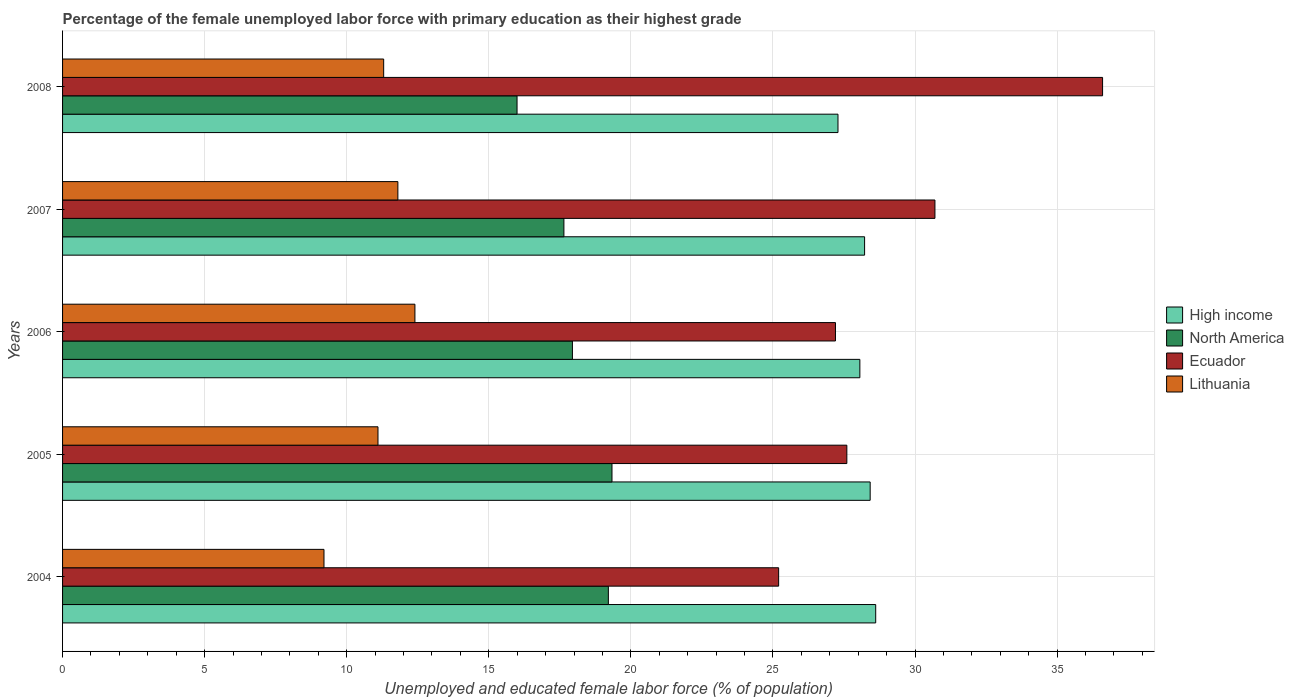How many different coloured bars are there?
Provide a short and direct response. 4. Are the number of bars on each tick of the Y-axis equal?
Provide a short and direct response. Yes. How many bars are there on the 1st tick from the top?
Ensure brevity in your answer.  4. How many bars are there on the 1st tick from the bottom?
Make the answer very short. 4. In how many cases, is the number of bars for a given year not equal to the number of legend labels?
Give a very brief answer. 0. What is the percentage of the unemployed female labor force with primary education in High income in 2006?
Ensure brevity in your answer.  28.06. Across all years, what is the maximum percentage of the unemployed female labor force with primary education in Ecuador?
Ensure brevity in your answer.  36.6. Across all years, what is the minimum percentage of the unemployed female labor force with primary education in High income?
Provide a short and direct response. 27.29. What is the total percentage of the unemployed female labor force with primary education in North America in the graph?
Provide a short and direct response. 90.12. What is the difference between the percentage of the unemployed female labor force with primary education in High income in 2007 and that in 2008?
Give a very brief answer. 0.94. What is the difference between the percentage of the unemployed female labor force with primary education in Lithuania in 2004 and the percentage of the unemployed female labor force with primary education in North America in 2008?
Provide a succinct answer. -6.79. What is the average percentage of the unemployed female labor force with primary education in High income per year?
Your answer should be very brief. 28.12. In the year 2005, what is the difference between the percentage of the unemployed female labor force with primary education in High income and percentage of the unemployed female labor force with primary education in Lithuania?
Your answer should be compact. 17.32. What is the ratio of the percentage of the unemployed female labor force with primary education in North America in 2005 to that in 2008?
Offer a terse response. 1.21. Is the difference between the percentage of the unemployed female labor force with primary education in High income in 2005 and 2007 greater than the difference between the percentage of the unemployed female labor force with primary education in Lithuania in 2005 and 2007?
Offer a very short reply. Yes. What is the difference between the highest and the second highest percentage of the unemployed female labor force with primary education in North America?
Keep it short and to the point. 0.13. What is the difference between the highest and the lowest percentage of the unemployed female labor force with primary education in Ecuador?
Keep it short and to the point. 11.4. In how many years, is the percentage of the unemployed female labor force with primary education in North America greater than the average percentage of the unemployed female labor force with primary education in North America taken over all years?
Provide a succinct answer. 2. Is the sum of the percentage of the unemployed female labor force with primary education in High income in 2004 and 2007 greater than the maximum percentage of the unemployed female labor force with primary education in North America across all years?
Your answer should be compact. Yes. What does the 2nd bar from the top in 2008 represents?
Provide a short and direct response. Ecuador. Is it the case that in every year, the sum of the percentage of the unemployed female labor force with primary education in Ecuador and percentage of the unemployed female labor force with primary education in Lithuania is greater than the percentage of the unemployed female labor force with primary education in North America?
Make the answer very short. Yes. How many years are there in the graph?
Ensure brevity in your answer.  5. What is the difference between two consecutive major ticks on the X-axis?
Provide a short and direct response. 5. Does the graph contain any zero values?
Keep it short and to the point. No. Does the graph contain grids?
Give a very brief answer. Yes. Where does the legend appear in the graph?
Make the answer very short. Center right. How many legend labels are there?
Offer a very short reply. 4. How are the legend labels stacked?
Your response must be concise. Vertical. What is the title of the graph?
Give a very brief answer. Percentage of the female unemployed labor force with primary education as their highest grade. Does "Singapore" appear as one of the legend labels in the graph?
Provide a short and direct response. No. What is the label or title of the X-axis?
Keep it short and to the point. Unemployed and educated female labor force (% of population). What is the label or title of the Y-axis?
Make the answer very short. Years. What is the Unemployed and educated female labor force (% of population) of High income in 2004?
Give a very brief answer. 28.62. What is the Unemployed and educated female labor force (% of population) in North America in 2004?
Make the answer very short. 19.21. What is the Unemployed and educated female labor force (% of population) of Ecuador in 2004?
Offer a terse response. 25.2. What is the Unemployed and educated female labor force (% of population) in Lithuania in 2004?
Offer a very short reply. 9.2. What is the Unemployed and educated female labor force (% of population) of High income in 2005?
Your response must be concise. 28.42. What is the Unemployed and educated female labor force (% of population) of North America in 2005?
Offer a terse response. 19.33. What is the Unemployed and educated female labor force (% of population) of Ecuador in 2005?
Make the answer very short. 27.6. What is the Unemployed and educated female labor force (% of population) of Lithuania in 2005?
Ensure brevity in your answer.  11.1. What is the Unemployed and educated female labor force (% of population) in High income in 2006?
Keep it short and to the point. 28.06. What is the Unemployed and educated female labor force (% of population) in North America in 2006?
Ensure brevity in your answer.  17.94. What is the Unemployed and educated female labor force (% of population) in Ecuador in 2006?
Your answer should be compact. 27.2. What is the Unemployed and educated female labor force (% of population) in Lithuania in 2006?
Offer a terse response. 12.4. What is the Unemployed and educated female labor force (% of population) in High income in 2007?
Your response must be concise. 28.22. What is the Unemployed and educated female labor force (% of population) of North America in 2007?
Your answer should be very brief. 17.64. What is the Unemployed and educated female labor force (% of population) in Ecuador in 2007?
Give a very brief answer. 30.7. What is the Unemployed and educated female labor force (% of population) in Lithuania in 2007?
Ensure brevity in your answer.  11.8. What is the Unemployed and educated female labor force (% of population) of High income in 2008?
Ensure brevity in your answer.  27.29. What is the Unemployed and educated female labor force (% of population) in North America in 2008?
Give a very brief answer. 15.99. What is the Unemployed and educated female labor force (% of population) of Ecuador in 2008?
Offer a terse response. 36.6. What is the Unemployed and educated female labor force (% of population) of Lithuania in 2008?
Your answer should be very brief. 11.3. Across all years, what is the maximum Unemployed and educated female labor force (% of population) in High income?
Ensure brevity in your answer.  28.62. Across all years, what is the maximum Unemployed and educated female labor force (% of population) of North America?
Your answer should be compact. 19.33. Across all years, what is the maximum Unemployed and educated female labor force (% of population) in Ecuador?
Ensure brevity in your answer.  36.6. Across all years, what is the maximum Unemployed and educated female labor force (% of population) of Lithuania?
Your response must be concise. 12.4. Across all years, what is the minimum Unemployed and educated female labor force (% of population) in High income?
Provide a succinct answer. 27.29. Across all years, what is the minimum Unemployed and educated female labor force (% of population) in North America?
Provide a short and direct response. 15.99. Across all years, what is the minimum Unemployed and educated female labor force (% of population) in Ecuador?
Keep it short and to the point. 25.2. Across all years, what is the minimum Unemployed and educated female labor force (% of population) of Lithuania?
Your response must be concise. 9.2. What is the total Unemployed and educated female labor force (% of population) of High income in the graph?
Provide a short and direct response. 140.61. What is the total Unemployed and educated female labor force (% of population) of North America in the graph?
Provide a short and direct response. 90.12. What is the total Unemployed and educated female labor force (% of population) of Ecuador in the graph?
Provide a short and direct response. 147.3. What is the total Unemployed and educated female labor force (% of population) of Lithuania in the graph?
Offer a terse response. 55.8. What is the difference between the Unemployed and educated female labor force (% of population) in High income in 2004 and that in 2005?
Ensure brevity in your answer.  0.19. What is the difference between the Unemployed and educated female labor force (% of population) in North America in 2004 and that in 2005?
Provide a succinct answer. -0.13. What is the difference between the Unemployed and educated female labor force (% of population) in High income in 2004 and that in 2006?
Give a very brief answer. 0.56. What is the difference between the Unemployed and educated female labor force (% of population) in North America in 2004 and that in 2006?
Offer a terse response. 1.26. What is the difference between the Unemployed and educated female labor force (% of population) of Lithuania in 2004 and that in 2006?
Provide a succinct answer. -3.2. What is the difference between the Unemployed and educated female labor force (% of population) of High income in 2004 and that in 2007?
Provide a short and direct response. 0.39. What is the difference between the Unemployed and educated female labor force (% of population) of North America in 2004 and that in 2007?
Make the answer very short. 1.56. What is the difference between the Unemployed and educated female labor force (% of population) of Ecuador in 2004 and that in 2007?
Your answer should be very brief. -5.5. What is the difference between the Unemployed and educated female labor force (% of population) of Lithuania in 2004 and that in 2007?
Ensure brevity in your answer.  -2.6. What is the difference between the Unemployed and educated female labor force (% of population) of High income in 2004 and that in 2008?
Ensure brevity in your answer.  1.33. What is the difference between the Unemployed and educated female labor force (% of population) of North America in 2004 and that in 2008?
Offer a very short reply. 3.21. What is the difference between the Unemployed and educated female labor force (% of population) of Ecuador in 2004 and that in 2008?
Provide a succinct answer. -11.4. What is the difference between the Unemployed and educated female labor force (% of population) in High income in 2005 and that in 2006?
Keep it short and to the point. 0.36. What is the difference between the Unemployed and educated female labor force (% of population) in North America in 2005 and that in 2006?
Give a very brief answer. 1.39. What is the difference between the Unemployed and educated female labor force (% of population) in Ecuador in 2005 and that in 2006?
Ensure brevity in your answer.  0.4. What is the difference between the Unemployed and educated female labor force (% of population) of High income in 2005 and that in 2007?
Make the answer very short. 0.2. What is the difference between the Unemployed and educated female labor force (% of population) in North America in 2005 and that in 2007?
Your response must be concise. 1.69. What is the difference between the Unemployed and educated female labor force (% of population) of High income in 2005 and that in 2008?
Your answer should be very brief. 1.13. What is the difference between the Unemployed and educated female labor force (% of population) in North America in 2005 and that in 2008?
Keep it short and to the point. 3.34. What is the difference between the Unemployed and educated female labor force (% of population) in Ecuador in 2005 and that in 2008?
Your answer should be very brief. -9. What is the difference between the Unemployed and educated female labor force (% of population) of High income in 2006 and that in 2007?
Your response must be concise. -0.17. What is the difference between the Unemployed and educated female labor force (% of population) of North America in 2006 and that in 2007?
Keep it short and to the point. 0.3. What is the difference between the Unemployed and educated female labor force (% of population) of Ecuador in 2006 and that in 2007?
Make the answer very short. -3.5. What is the difference between the Unemployed and educated female labor force (% of population) of Lithuania in 2006 and that in 2007?
Offer a very short reply. 0.6. What is the difference between the Unemployed and educated female labor force (% of population) of High income in 2006 and that in 2008?
Ensure brevity in your answer.  0.77. What is the difference between the Unemployed and educated female labor force (% of population) in North America in 2006 and that in 2008?
Make the answer very short. 1.95. What is the difference between the Unemployed and educated female labor force (% of population) of High income in 2007 and that in 2008?
Offer a terse response. 0.94. What is the difference between the Unemployed and educated female labor force (% of population) in North America in 2007 and that in 2008?
Give a very brief answer. 1.65. What is the difference between the Unemployed and educated female labor force (% of population) of Lithuania in 2007 and that in 2008?
Make the answer very short. 0.5. What is the difference between the Unemployed and educated female labor force (% of population) of High income in 2004 and the Unemployed and educated female labor force (% of population) of North America in 2005?
Offer a terse response. 9.28. What is the difference between the Unemployed and educated female labor force (% of population) of High income in 2004 and the Unemployed and educated female labor force (% of population) of Ecuador in 2005?
Your answer should be compact. 1.02. What is the difference between the Unemployed and educated female labor force (% of population) in High income in 2004 and the Unemployed and educated female labor force (% of population) in Lithuania in 2005?
Your answer should be very brief. 17.52. What is the difference between the Unemployed and educated female labor force (% of population) in North America in 2004 and the Unemployed and educated female labor force (% of population) in Ecuador in 2005?
Offer a very short reply. -8.39. What is the difference between the Unemployed and educated female labor force (% of population) in North America in 2004 and the Unemployed and educated female labor force (% of population) in Lithuania in 2005?
Keep it short and to the point. 8.11. What is the difference between the Unemployed and educated female labor force (% of population) in Ecuador in 2004 and the Unemployed and educated female labor force (% of population) in Lithuania in 2005?
Ensure brevity in your answer.  14.1. What is the difference between the Unemployed and educated female labor force (% of population) in High income in 2004 and the Unemployed and educated female labor force (% of population) in North America in 2006?
Make the answer very short. 10.67. What is the difference between the Unemployed and educated female labor force (% of population) in High income in 2004 and the Unemployed and educated female labor force (% of population) in Ecuador in 2006?
Give a very brief answer. 1.42. What is the difference between the Unemployed and educated female labor force (% of population) of High income in 2004 and the Unemployed and educated female labor force (% of population) of Lithuania in 2006?
Offer a terse response. 16.22. What is the difference between the Unemployed and educated female labor force (% of population) of North America in 2004 and the Unemployed and educated female labor force (% of population) of Ecuador in 2006?
Provide a succinct answer. -7.99. What is the difference between the Unemployed and educated female labor force (% of population) of North America in 2004 and the Unemployed and educated female labor force (% of population) of Lithuania in 2006?
Ensure brevity in your answer.  6.81. What is the difference between the Unemployed and educated female labor force (% of population) of High income in 2004 and the Unemployed and educated female labor force (% of population) of North America in 2007?
Offer a terse response. 10.97. What is the difference between the Unemployed and educated female labor force (% of population) of High income in 2004 and the Unemployed and educated female labor force (% of population) of Ecuador in 2007?
Give a very brief answer. -2.08. What is the difference between the Unemployed and educated female labor force (% of population) in High income in 2004 and the Unemployed and educated female labor force (% of population) in Lithuania in 2007?
Ensure brevity in your answer.  16.82. What is the difference between the Unemployed and educated female labor force (% of population) in North America in 2004 and the Unemployed and educated female labor force (% of population) in Ecuador in 2007?
Keep it short and to the point. -11.49. What is the difference between the Unemployed and educated female labor force (% of population) of North America in 2004 and the Unemployed and educated female labor force (% of population) of Lithuania in 2007?
Offer a terse response. 7.41. What is the difference between the Unemployed and educated female labor force (% of population) in High income in 2004 and the Unemployed and educated female labor force (% of population) in North America in 2008?
Offer a terse response. 12.62. What is the difference between the Unemployed and educated female labor force (% of population) in High income in 2004 and the Unemployed and educated female labor force (% of population) in Ecuador in 2008?
Provide a succinct answer. -7.98. What is the difference between the Unemployed and educated female labor force (% of population) of High income in 2004 and the Unemployed and educated female labor force (% of population) of Lithuania in 2008?
Your answer should be compact. 17.32. What is the difference between the Unemployed and educated female labor force (% of population) of North America in 2004 and the Unemployed and educated female labor force (% of population) of Ecuador in 2008?
Provide a short and direct response. -17.39. What is the difference between the Unemployed and educated female labor force (% of population) in North America in 2004 and the Unemployed and educated female labor force (% of population) in Lithuania in 2008?
Keep it short and to the point. 7.91. What is the difference between the Unemployed and educated female labor force (% of population) in Ecuador in 2004 and the Unemployed and educated female labor force (% of population) in Lithuania in 2008?
Make the answer very short. 13.9. What is the difference between the Unemployed and educated female labor force (% of population) in High income in 2005 and the Unemployed and educated female labor force (% of population) in North America in 2006?
Provide a succinct answer. 10.48. What is the difference between the Unemployed and educated female labor force (% of population) in High income in 2005 and the Unemployed and educated female labor force (% of population) in Ecuador in 2006?
Ensure brevity in your answer.  1.22. What is the difference between the Unemployed and educated female labor force (% of population) of High income in 2005 and the Unemployed and educated female labor force (% of population) of Lithuania in 2006?
Your answer should be very brief. 16.02. What is the difference between the Unemployed and educated female labor force (% of population) in North America in 2005 and the Unemployed and educated female labor force (% of population) in Ecuador in 2006?
Make the answer very short. -7.87. What is the difference between the Unemployed and educated female labor force (% of population) in North America in 2005 and the Unemployed and educated female labor force (% of population) in Lithuania in 2006?
Keep it short and to the point. 6.93. What is the difference between the Unemployed and educated female labor force (% of population) of High income in 2005 and the Unemployed and educated female labor force (% of population) of North America in 2007?
Ensure brevity in your answer.  10.78. What is the difference between the Unemployed and educated female labor force (% of population) in High income in 2005 and the Unemployed and educated female labor force (% of population) in Ecuador in 2007?
Ensure brevity in your answer.  -2.28. What is the difference between the Unemployed and educated female labor force (% of population) of High income in 2005 and the Unemployed and educated female labor force (% of population) of Lithuania in 2007?
Keep it short and to the point. 16.62. What is the difference between the Unemployed and educated female labor force (% of population) in North America in 2005 and the Unemployed and educated female labor force (% of population) in Ecuador in 2007?
Provide a succinct answer. -11.37. What is the difference between the Unemployed and educated female labor force (% of population) of North America in 2005 and the Unemployed and educated female labor force (% of population) of Lithuania in 2007?
Make the answer very short. 7.53. What is the difference between the Unemployed and educated female labor force (% of population) of High income in 2005 and the Unemployed and educated female labor force (% of population) of North America in 2008?
Your response must be concise. 12.43. What is the difference between the Unemployed and educated female labor force (% of population) of High income in 2005 and the Unemployed and educated female labor force (% of population) of Ecuador in 2008?
Keep it short and to the point. -8.18. What is the difference between the Unemployed and educated female labor force (% of population) of High income in 2005 and the Unemployed and educated female labor force (% of population) of Lithuania in 2008?
Give a very brief answer. 17.12. What is the difference between the Unemployed and educated female labor force (% of population) in North America in 2005 and the Unemployed and educated female labor force (% of population) in Ecuador in 2008?
Make the answer very short. -17.27. What is the difference between the Unemployed and educated female labor force (% of population) of North America in 2005 and the Unemployed and educated female labor force (% of population) of Lithuania in 2008?
Your answer should be very brief. 8.03. What is the difference between the Unemployed and educated female labor force (% of population) of Ecuador in 2005 and the Unemployed and educated female labor force (% of population) of Lithuania in 2008?
Offer a very short reply. 16.3. What is the difference between the Unemployed and educated female labor force (% of population) of High income in 2006 and the Unemployed and educated female labor force (% of population) of North America in 2007?
Your response must be concise. 10.42. What is the difference between the Unemployed and educated female labor force (% of population) in High income in 2006 and the Unemployed and educated female labor force (% of population) in Ecuador in 2007?
Keep it short and to the point. -2.64. What is the difference between the Unemployed and educated female labor force (% of population) of High income in 2006 and the Unemployed and educated female labor force (% of population) of Lithuania in 2007?
Your answer should be compact. 16.26. What is the difference between the Unemployed and educated female labor force (% of population) of North America in 2006 and the Unemployed and educated female labor force (% of population) of Ecuador in 2007?
Offer a terse response. -12.76. What is the difference between the Unemployed and educated female labor force (% of population) of North America in 2006 and the Unemployed and educated female labor force (% of population) of Lithuania in 2007?
Offer a terse response. 6.14. What is the difference between the Unemployed and educated female labor force (% of population) of Ecuador in 2006 and the Unemployed and educated female labor force (% of population) of Lithuania in 2007?
Your answer should be very brief. 15.4. What is the difference between the Unemployed and educated female labor force (% of population) of High income in 2006 and the Unemployed and educated female labor force (% of population) of North America in 2008?
Provide a succinct answer. 12.06. What is the difference between the Unemployed and educated female labor force (% of population) in High income in 2006 and the Unemployed and educated female labor force (% of population) in Ecuador in 2008?
Keep it short and to the point. -8.54. What is the difference between the Unemployed and educated female labor force (% of population) of High income in 2006 and the Unemployed and educated female labor force (% of population) of Lithuania in 2008?
Make the answer very short. 16.76. What is the difference between the Unemployed and educated female labor force (% of population) of North America in 2006 and the Unemployed and educated female labor force (% of population) of Ecuador in 2008?
Provide a succinct answer. -18.66. What is the difference between the Unemployed and educated female labor force (% of population) of North America in 2006 and the Unemployed and educated female labor force (% of population) of Lithuania in 2008?
Keep it short and to the point. 6.64. What is the difference between the Unemployed and educated female labor force (% of population) in High income in 2007 and the Unemployed and educated female labor force (% of population) in North America in 2008?
Make the answer very short. 12.23. What is the difference between the Unemployed and educated female labor force (% of population) in High income in 2007 and the Unemployed and educated female labor force (% of population) in Ecuador in 2008?
Ensure brevity in your answer.  -8.38. What is the difference between the Unemployed and educated female labor force (% of population) in High income in 2007 and the Unemployed and educated female labor force (% of population) in Lithuania in 2008?
Provide a succinct answer. 16.92. What is the difference between the Unemployed and educated female labor force (% of population) of North America in 2007 and the Unemployed and educated female labor force (% of population) of Ecuador in 2008?
Your answer should be very brief. -18.96. What is the difference between the Unemployed and educated female labor force (% of population) in North America in 2007 and the Unemployed and educated female labor force (% of population) in Lithuania in 2008?
Provide a short and direct response. 6.34. What is the difference between the Unemployed and educated female labor force (% of population) of Ecuador in 2007 and the Unemployed and educated female labor force (% of population) of Lithuania in 2008?
Keep it short and to the point. 19.4. What is the average Unemployed and educated female labor force (% of population) in High income per year?
Make the answer very short. 28.12. What is the average Unemployed and educated female labor force (% of population) in North America per year?
Ensure brevity in your answer.  18.02. What is the average Unemployed and educated female labor force (% of population) of Ecuador per year?
Your answer should be very brief. 29.46. What is the average Unemployed and educated female labor force (% of population) in Lithuania per year?
Your answer should be very brief. 11.16. In the year 2004, what is the difference between the Unemployed and educated female labor force (% of population) in High income and Unemployed and educated female labor force (% of population) in North America?
Ensure brevity in your answer.  9.41. In the year 2004, what is the difference between the Unemployed and educated female labor force (% of population) of High income and Unemployed and educated female labor force (% of population) of Ecuador?
Provide a short and direct response. 3.42. In the year 2004, what is the difference between the Unemployed and educated female labor force (% of population) of High income and Unemployed and educated female labor force (% of population) of Lithuania?
Keep it short and to the point. 19.42. In the year 2004, what is the difference between the Unemployed and educated female labor force (% of population) in North America and Unemployed and educated female labor force (% of population) in Ecuador?
Offer a terse response. -5.99. In the year 2004, what is the difference between the Unemployed and educated female labor force (% of population) of North America and Unemployed and educated female labor force (% of population) of Lithuania?
Make the answer very short. 10.01. In the year 2004, what is the difference between the Unemployed and educated female labor force (% of population) of Ecuador and Unemployed and educated female labor force (% of population) of Lithuania?
Provide a short and direct response. 16. In the year 2005, what is the difference between the Unemployed and educated female labor force (% of population) in High income and Unemployed and educated female labor force (% of population) in North America?
Ensure brevity in your answer.  9.09. In the year 2005, what is the difference between the Unemployed and educated female labor force (% of population) in High income and Unemployed and educated female labor force (% of population) in Ecuador?
Provide a short and direct response. 0.82. In the year 2005, what is the difference between the Unemployed and educated female labor force (% of population) of High income and Unemployed and educated female labor force (% of population) of Lithuania?
Ensure brevity in your answer.  17.32. In the year 2005, what is the difference between the Unemployed and educated female labor force (% of population) in North America and Unemployed and educated female labor force (% of population) in Ecuador?
Ensure brevity in your answer.  -8.27. In the year 2005, what is the difference between the Unemployed and educated female labor force (% of population) in North America and Unemployed and educated female labor force (% of population) in Lithuania?
Keep it short and to the point. 8.23. In the year 2005, what is the difference between the Unemployed and educated female labor force (% of population) of Ecuador and Unemployed and educated female labor force (% of population) of Lithuania?
Your answer should be compact. 16.5. In the year 2006, what is the difference between the Unemployed and educated female labor force (% of population) of High income and Unemployed and educated female labor force (% of population) of North America?
Your answer should be very brief. 10.12. In the year 2006, what is the difference between the Unemployed and educated female labor force (% of population) of High income and Unemployed and educated female labor force (% of population) of Ecuador?
Ensure brevity in your answer.  0.86. In the year 2006, what is the difference between the Unemployed and educated female labor force (% of population) of High income and Unemployed and educated female labor force (% of population) of Lithuania?
Your answer should be compact. 15.66. In the year 2006, what is the difference between the Unemployed and educated female labor force (% of population) in North America and Unemployed and educated female labor force (% of population) in Ecuador?
Your response must be concise. -9.26. In the year 2006, what is the difference between the Unemployed and educated female labor force (% of population) in North America and Unemployed and educated female labor force (% of population) in Lithuania?
Provide a short and direct response. 5.54. In the year 2007, what is the difference between the Unemployed and educated female labor force (% of population) in High income and Unemployed and educated female labor force (% of population) in North America?
Your response must be concise. 10.58. In the year 2007, what is the difference between the Unemployed and educated female labor force (% of population) in High income and Unemployed and educated female labor force (% of population) in Ecuador?
Give a very brief answer. -2.48. In the year 2007, what is the difference between the Unemployed and educated female labor force (% of population) of High income and Unemployed and educated female labor force (% of population) of Lithuania?
Your response must be concise. 16.42. In the year 2007, what is the difference between the Unemployed and educated female labor force (% of population) of North America and Unemployed and educated female labor force (% of population) of Ecuador?
Ensure brevity in your answer.  -13.06. In the year 2007, what is the difference between the Unemployed and educated female labor force (% of population) of North America and Unemployed and educated female labor force (% of population) of Lithuania?
Your answer should be compact. 5.84. In the year 2008, what is the difference between the Unemployed and educated female labor force (% of population) in High income and Unemployed and educated female labor force (% of population) in North America?
Offer a terse response. 11.29. In the year 2008, what is the difference between the Unemployed and educated female labor force (% of population) of High income and Unemployed and educated female labor force (% of population) of Ecuador?
Offer a very short reply. -9.31. In the year 2008, what is the difference between the Unemployed and educated female labor force (% of population) in High income and Unemployed and educated female labor force (% of population) in Lithuania?
Offer a terse response. 15.99. In the year 2008, what is the difference between the Unemployed and educated female labor force (% of population) of North America and Unemployed and educated female labor force (% of population) of Ecuador?
Your response must be concise. -20.61. In the year 2008, what is the difference between the Unemployed and educated female labor force (% of population) in North America and Unemployed and educated female labor force (% of population) in Lithuania?
Your answer should be compact. 4.69. In the year 2008, what is the difference between the Unemployed and educated female labor force (% of population) in Ecuador and Unemployed and educated female labor force (% of population) in Lithuania?
Keep it short and to the point. 25.3. What is the ratio of the Unemployed and educated female labor force (% of population) of Lithuania in 2004 to that in 2005?
Give a very brief answer. 0.83. What is the ratio of the Unemployed and educated female labor force (% of population) in High income in 2004 to that in 2006?
Offer a very short reply. 1.02. What is the ratio of the Unemployed and educated female labor force (% of population) of North America in 2004 to that in 2006?
Provide a short and direct response. 1.07. What is the ratio of the Unemployed and educated female labor force (% of population) of Ecuador in 2004 to that in 2006?
Your response must be concise. 0.93. What is the ratio of the Unemployed and educated female labor force (% of population) of Lithuania in 2004 to that in 2006?
Offer a terse response. 0.74. What is the ratio of the Unemployed and educated female labor force (% of population) in High income in 2004 to that in 2007?
Give a very brief answer. 1.01. What is the ratio of the Unemployed and educated female labor force (% of population) in North America in 2004 to that in 2007?
Provide a short and direct response. 1.09. What is the ratio of the Unemployed and educated female labor force (% of population) in Ecuador in 2004 to that in 2007?
Offer a very short reply. 0.82. What is the ratio of the Unemployed and educated female labor force (% of population) in Lithuania in 2004 to that in 2007?
Offer a terse response. 0.78. What is the ratio of the Unemployed and educated female labor force (% of population) in High income in 2004 to that in 2008?
Your answer should be very brief. 1.05. What is the ratio of the Unemployed and educated female labor force (% of population) in North America in 2004 to that in 2008?
Offer a very short reply. 1.2. What is the ratio of the Unemployed and educated female labor force (% of population) in Ecuador in 2004 to that in 2008?
Provide a succinct answer. 0.69. What is the ratio of the Unemployed and educated female labor force (% of population) of Lithuania in 2004 to that in 2008?
Offer a terse response. 0.81. What is the ratio of the Unemployed and educated female labor force (% of population) in High income in 2005 to that in 2006?
Your answer should be compact. 1.01. What is the ratio of the Unemployed and educated female labor force (% of population) of North America in 2005 to that in 2006?
Your answer should be compact. 1.08. What is the ratio of the Unemployed and educated female labor force (% of population) in Ecuador in 2005 to that in 2006?
Provide a short and direct response. 1.01. What is the ratio of the Unemployed and educated female labor force (% of population) in Lithuania in 2005 to that in 2006?
Ensure brevity in your answer.  0.9. What is the ratio of the Unemployed and educated female labor force (% of population) of North America in 2005 to that in 2007?
Make the answer very short. 1.1. What is the ratio of the Unemployed and educated female labor force (% of population) in Ecuador in 2005 to that in 2007?
Offer a very short reply. 0.9. What is the ratio of the Unemployed and educated female labor force (% of population) in Lithuania in 2005 to that in 2007?
Ensure brevity in your answer.  0.94. What is the ratio of the Unemployed and educated female labor force (% of population) in High income in 2005 to that in 2008?
Your response must be concise. 1.04. What is the ratio of the Unemployed and educated female labor force (% of population) in North America in 2005 to that in 2008?
Your answer should be compact. 1.21. What is the ratio of the Unemployed and educated female labor force (% of population) in Ecuador in 2005 to that in 2008?
Give a very brief answer. 0.75. What is the ratio of the Unemployed and educated female labor force (% of population) of Lithuania in 2005 to that in 2008?
Give a very brief answer. 0.98. What is the ratio of the Unemployed and educated female labor force (% of population) of North America in 2006 to that in 2007?
Provide a succinct answer. 1.02. What is the ratio of the Unemployed and educated female labor force (% of population) of Ecuador in 2006 to that in 2007?
Provide a short and direct response. 0.89. What is the ratio of the Unemployed and educated female labor force (% of population) in Lithuania in 2006 to that in 2007?
Your answer should be compact. 1.05. What is the ratio of the Unemployed and educated female labor force (% of population) in High income in 2006 to that in 2008?
Ensure brevity in your answer.  1.03. What is the ratio of the Unemployed and educated female labor force (% of population) in North America in 2006 to that in 2008?
Your answer should be compact. 1.12. What is the ratio of the Unemployed and educated female labor force (% of population) of Ecuador in 2006 to that in 2008?
Ensure brevity in your answer.  0.74. What is the ratio of the Unemployed and educated female labor force (% of population) of Lithuania in 2006 to that in 2008?
Ensure brevity in your answer.  1.1. What is the ratio of the Unemployed and educated female labor force (% of population) in High income in 2007 to that in 2008?
Offer a terse response. 1.03. What is the ratio of the Unemployed and educated female labor force (% of population) of North America in 2007 to that in 2008?
Ensure brevity in your answer.  1.1. What is the ratio of the Unemployed and educated female labor force (% of population) in Ecuador in 2007 to that in 2008?
Provide a short and direct response. 0.84. What is the ratio of the Unemployed and educated female labor force (% of population) in Lithuania in 2007 to that in 2008?
Your answer should be very brief. 1.04. What is the difference between the highest and the second highest Unemployed and educated female labor force (% of population) in High income?
Give a very brief answer. 0.19. What is the difference between the highest and the second highest Unemployed and educated female labor force (% of population) of North America?
Offer a terse response. 0.13. What is the difference between the highest and the second highest Unemployed and educated female labor force (% of population) in Lithuania?
Your answer should be very brief. 0.6. What is the difference between the highest and the lowest Unemployed and educated female labor force (% of population) in High income?
Offer a terse response. 1.33. What is the difference between the highest and the lowest Unemployed and educated female labor force (% of population) of North America?
Keep it short and to the point. 3.34. What is the difference between the highest and the lowest Unemployed and educated female labor force (% of population) of Ecuador?
Provide a short and direct response. 11.4. 